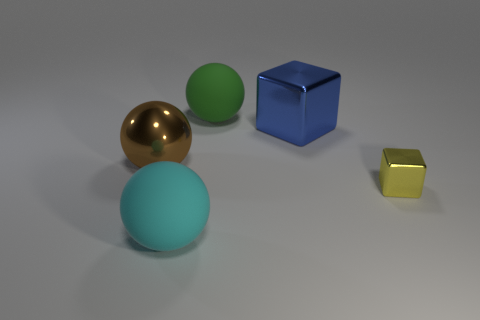Add 3 cyan shiny things. How many objects exist? 8 Subtract all balls. How many objects are left? 2 Add 5 large brown metallic cylinders. How many large brown metallic cylinders exist? 5 Subtract 0 purple spheres. How many objects are left? 5 Subtract all large things. Subtract all large blue metal cylinders. How many objects are left? 1 Add 1 cyan balls. How many cyan balls are left? 2 